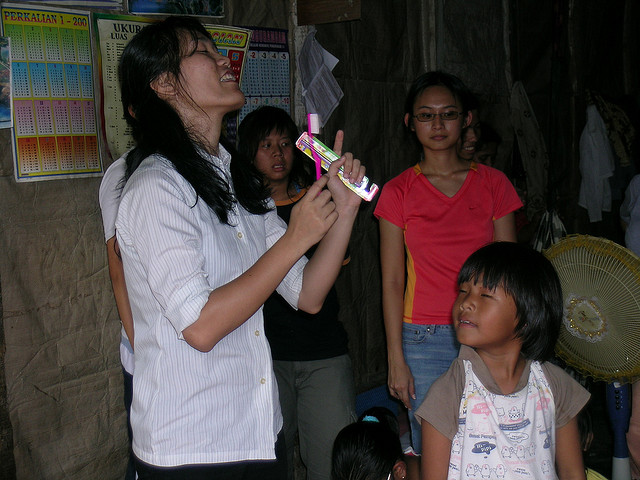Please transcribe the text information in this image. GIAN PERKALIAN 